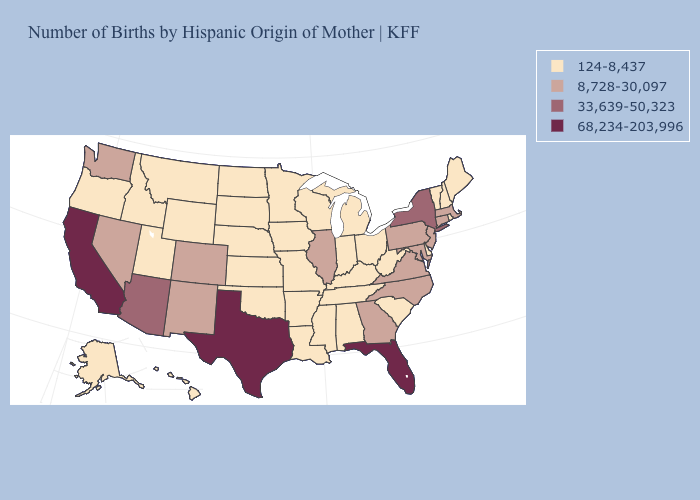Does the first symbol in the legend represent the smallest category?
Answer briefly. Yes. Which states hav the highest value in the South?
Write a very short answer. Florida, Texas. What is the value of Tennessee?
Write a very short answer. 124-8,437. What is the value of Vermont?
Give a very brief answer. 124-8,437. Does Iowa have the highest value in the USA?
Quick response, please. No. What is the lowest value in states that border Florida?
Be succinct. 124-8,437. What is the value of West Virginia?
Write a very short answer. 124-8,437. How many symbols are there in the legend?
Write a very short answer. 4. What is the value of Maine?
Write a very short answer. 124-8,437. Name the states that have a value in the range 33,639-50,323?
Write a very short answer. Arizona, New York. What is the lowest value in states that border Oregon?
Be succinct. 124-8,437. Does Georgia have a higher value than New Jersey?
Give a very brief answer. No. Which states have the highest value in the USA?
Keep it brief. California, Florida, Texas. What is the highest value in states that border Kansas?
Give a very brief answer. 8,728-30,097. Name the states that have a value in the range 68,234-203,996?
Be succinct. California, Florida, Texas. 